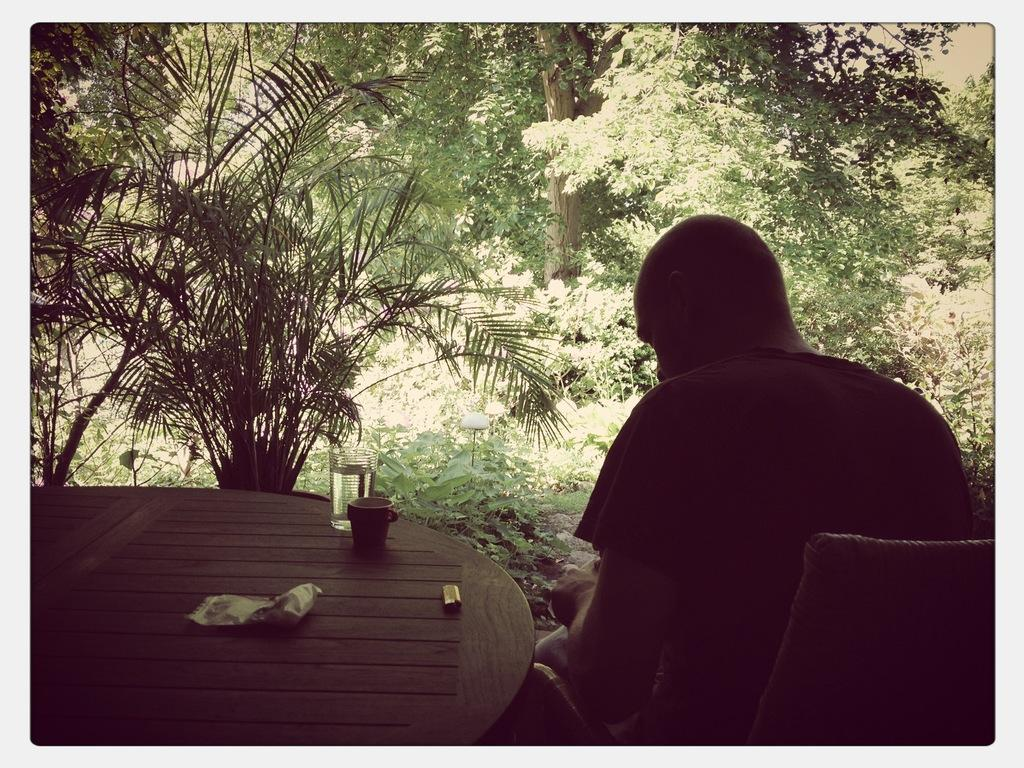What is the person in the image doing? The person is sitting on a chair in the image. What is in front of the person? The person is in front of a table. What objects can be seen on the table? There are glasses on the table. What type of natural elements are visible in the image? There are trees and plants visible in the image. What type of stamp can be seen on the person's forehead in the image? There is no stamp visible on the person's forehead in the image. What kind of arch is present in the image? There is no arch present in the image. 